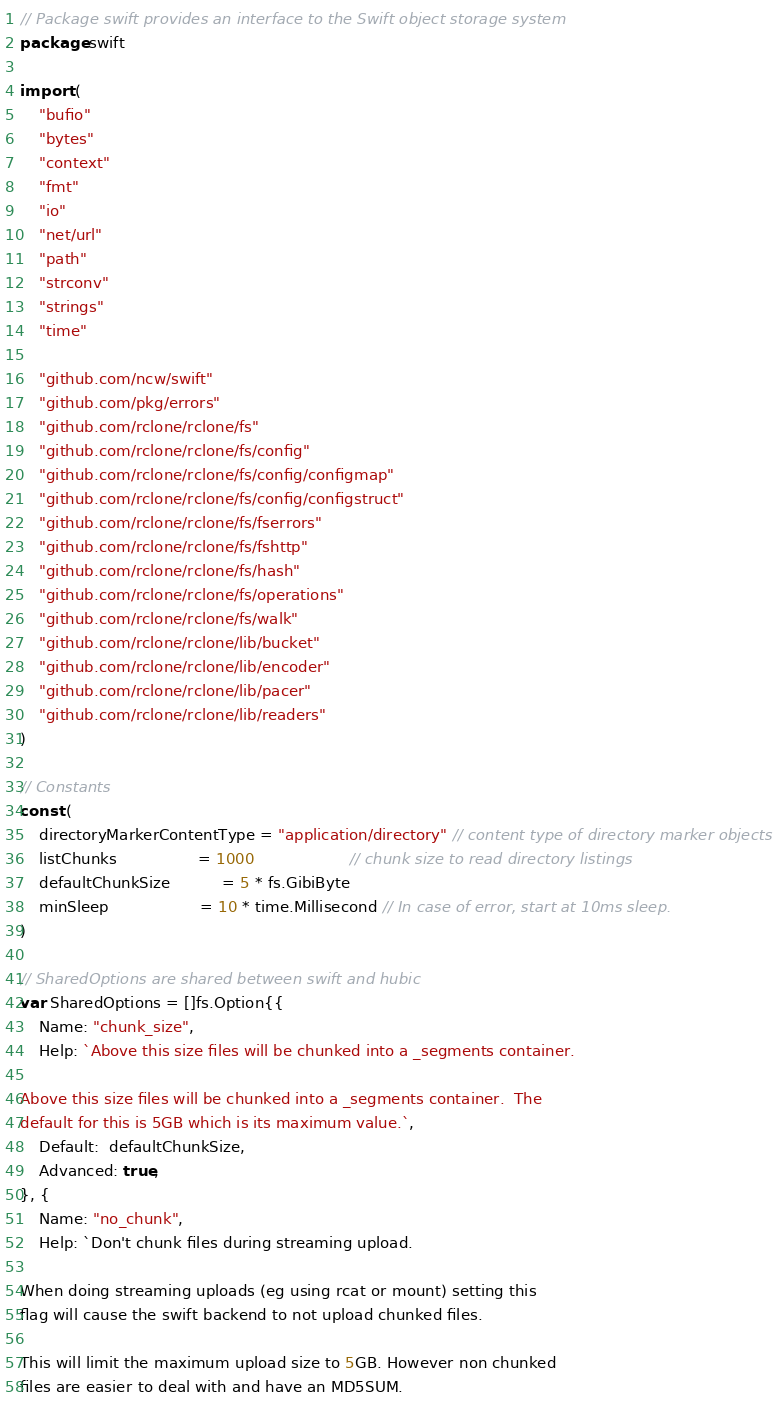Convert code to text. <code><loc_0><loc_0><loc_500><loc_500><_Go_>// Package swift provides an interface to the Swift object storage system
package swift

import (
	"bufio"
	"bytes"
	"context"
	"fmt"
	"io"
	"net/url"
	"path"
	"strconv"
	"strings"
	"time"

	"github.com/ncw/swift"
	"github.com/pkg/errors"
	"github.com/rclone/rclone/fs"
	"github.com/rclone/rclone/fs/config"
	"github.com/rclone/rclone/fs/config/configmap"
	"github.com/rclone/rclone/fs/config/configstruct"
	"github.com/rclone/rclone/fs/fserrors"
	"github.com/rclone/rclone/fs/fshttp"
	"github.com/rclone/rclone/fs/hash"
	"github.com/rclone/rclone/fs/operations"
	"github.com/rclone/rclone/fs/walk"
	"github.com/rclone/rclone/lib/bucket"
	"github.com/rclone/rclone/lib/encoder"
	"github.com/rclone/rclone/lib/pacer"
	"github.com/rclone/rclone/lib/readers"
)

// Constants
const (
	directoryMarkerContentType = "application/directory" // content type of directory marker objects
	listChunks                 = 1000                    // chunk size to read directory listings
	defaultChunkSize           = 5 * fs.GibiByte
	minSleep                   = 10 * time.Millisecond // In case of error, start at 10ms sleep.
)

// SharedOptions are shared between swift and hubic
var SharedOptions = []fs.Option{{
	Name: "chunk_size",
	Help: `Above this size files will be chunked into a _segments container.

Above this size files will be chunked into a _segments container.  The
default for this is 5GB which is its maximum value.`,
	Default:  defaultChunkSize,
	Advanced: true,
}, {
	Name: "no_chunk",
	Help: `Don't chunk files during streaming upload.

When doing streaming uploads (eg using rcat or mount) setting this
flag will cause the swift backend to not upload chunked files.

This will limit the maximum upload size to 5GB. However non chunked
files are easier to deal with and have an MD5SUM.
</code> 